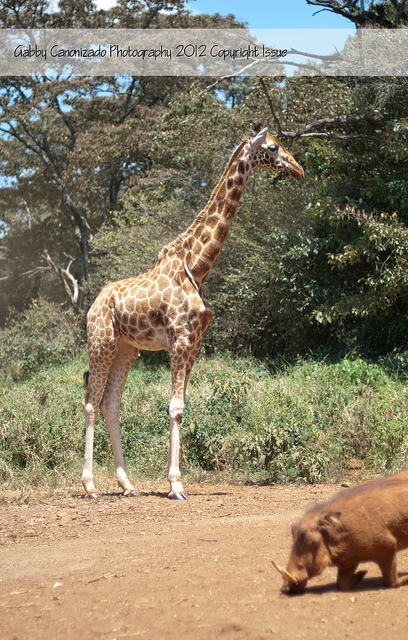Identify and read out the text in this image. Gabby Canonizado Photography 2012 Copyright Issue 